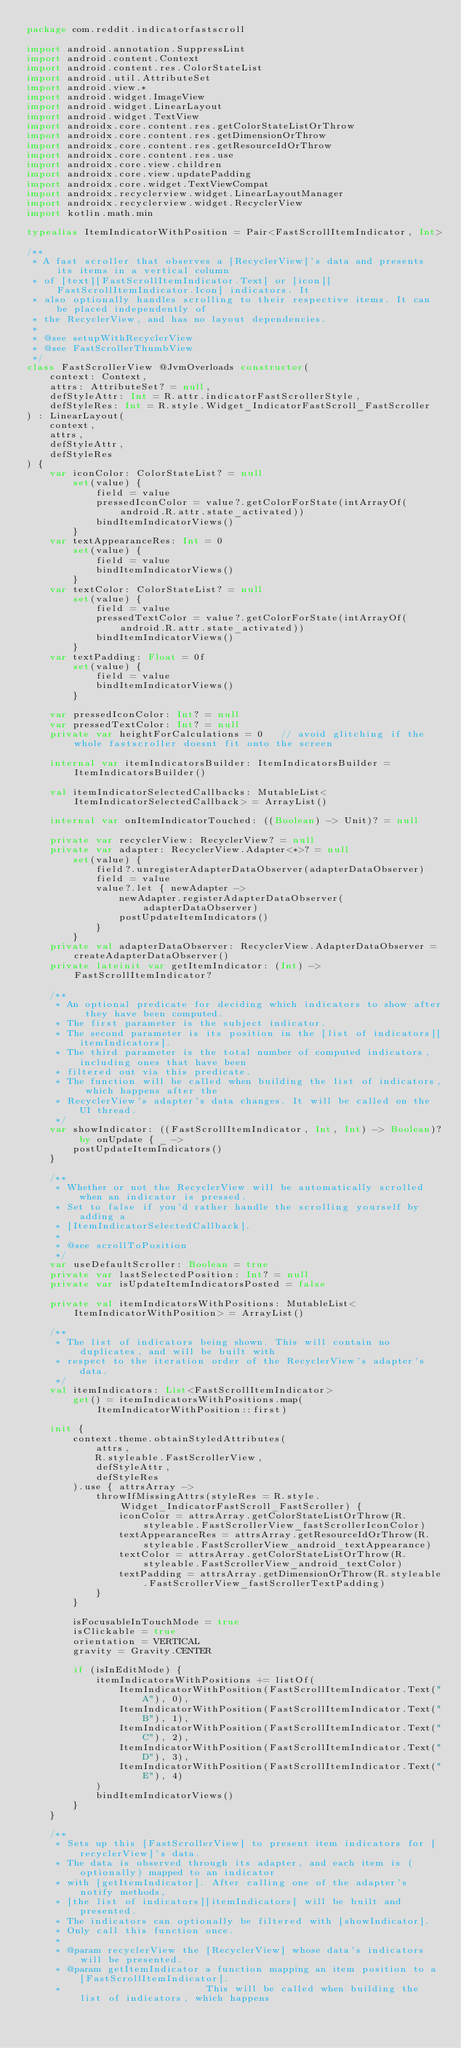Convert code to text. <code><loc_0><loc_0><loc_500><loc_500><_Kotlin_>package com.reddit.indicatorfastscroll

import android.annotation.SuppressLint
import android.content.Context
import android.content.res.ColorStateList
import android.util.AttributeSet
import android.view.*
import android.widget.ImageView
import android.widget.LinearLayout
import android.widget.TextView
import androidx.core.content.res.getColorStateListOrThrow
import androidx.core.content.res.getDimensionOrThrow
import androidx.core.content.res.getResourceIdOrThrow
import androidx.core.content.res.use
import androidx.core.view.children
import androidx.core.view.updatePadding
import androidx.core.widget.TextViewCompat
import androidx.recyclerview.widget.LinearLayoutManager
import androidx.recyclerview.widget.RecyclerView
import kotlin.math.min

typealias ItemIndicatorWithPosition = Pair<FastScrollItemIndicator, Int>

/**
 * A fast scroller that observes a [RecyclerView]'s data and presents its items in a vertical column
 * of [text][FastScrollItemIndicator.Text] or [icon][FastScrollItemIndicator.Icon] indicators. It
 * also optionally handles scrolling to their respective items. It can be placed independently of
 * the RecyclerView, and has no layout dependencies.
 *
 * @see setupWithRecyclerView
 * @see FastScrollerThumbView
 */
class FastScrollerView @JvmOverloads constructor(
    context: Context,
    attrs: AttributeSet? = null,
    defStyleAttr: Int = R.attr.indicatorFastScrollerStyle,
    defStyleRes: Int = R.style.Widget_IndicatorFastScroll_FastScroller
) : LinearLayout(
    context,
    attrs,
    defStyleAttr,
    defStyleRes
) {
    var iconColor: ColorStateList? = null
        set(value) {
            field = value
            pressedIconColor = value?.getColorForState(intArrayOf(android.R.attr.state_activated))
            bindItemIndicatorViews()
        }
    var textAppearanceRes: Int = 0
        set(value) {
            field = value
            bindItemIndicatorViews()
        }
    var textColor: ColorStateList? = null
        set(value) {
            field = value
            pressedTextColor = value?.getColorForState(intArrayOf(android.R.attr.state_activated))
            bindItemIndicatorViews()
        }
    var textPadding: Float = 0f
        set(value) {
            field = value
            bindItemIndicatorViews()
        }

    var pressedIconColor: Int? = null
    var pressedTextColor: Int? = null
    private var heightForCalculations = 0   // avoid glitching if the whole fastscroller doesnt fit onto the screen

    internal var itemIndicatorsBuilder: ItemIndicatorsBuilder = ItemIndicatorsBuilder()

    val itemIndicatorSelectedCallbacks: MutableList<ItemIndicatorSelectedCallback> = ArrayList()

    internal var onItemIndicatorTouched: ((Boolean) -> Unit)? = null

    private var recyclerView: RecyclerView? = null
    private var adapter: RecyclerView.Adapter<*>? = null
        set(value) {
            field?.unregisterAdapterDataObserver(adapterDataObserver)
            field = value
            value?.let { newAdapter ->
                newAdapter.registerAdapterDataObserver(adapterDataObserver)
                postUpdateItemIndicators()
            }
        }
    private val adapterDataObserver: RecyclerView.AdapterDataObserver = createAdapterDataObserver()
    private lateinit var getItemIndicator: (Int) -> FastScrollItemIndicator?

    /**
     * An optional predicate for deciding which indicators to show after they have been computed.
     * The first parameter is the subject indicator.
     * The second parameter is its position in the [list of indicators][itemIndicators].
     * The third parameter is the total number of computed indicators, including ones that have been
     * filtered out via this predicate.
     * The function will be called when building the list of indicators, which happens after the
     * RecyclerView's adapter's data changes. It will be called on the UI thread.
     */
    var showIndicator: ((FastScrollItemIndicator, Int, Int) -> Boolean)? by onUpdate { _ ->
        postUpdateItemIndicators()
    }

    /**
     * Whether or not the RecyclerView will be automatically scrolled when an indicator is pressed.
     * Set to false if you'd rather handle the scrolling yourself by adding a
     * [ItemIndicatorSelectedCallback].
     *
     * @see scrollToPosition
     */
    var useDefaultScroller: Boolean = true
    private var lastSelectedPosition: Int? = null
    private var isUpdateItemIndicatorsPosted = false

    private val itemIndicatorsWithPositions: MutableList<ItemIndicatorWithPosition> = ArrayList()

    /**
     * The list of indicators being shown. This will contain no duplicates, and will be built with
     * respect to the iteration order of the RecyclerView's adapter's data.
     */
    val itemIndicators: List<FastScrollItemIndicator>
        get() = itemIndicatorsWithPositions.map(ItemIndicatorWithPosition::first)

    init {
        context.theme.obtainStyledAttributes(
            attrs,
            R.styleable.FastScrollerView,
            defStyleAttr,
            defStyleRes
        ).use { attrsArray ->
            throwIfMissingAttrs(styleRes = R.style.Widget_IndicatorFastScroll_FastScroller) {
                iconColor = attrsArray.getColorStateListOrThrow(R.styleable.FastScrollerView_fastScrollerIconColor)
                textAppearanceRes = attrsArray.getResourceIdOrThrow(R.styleable.FastScrollerView_android_textAppearance)
                textColor = attrsArray.getColorStateListOrThrow(R.styleable.FastScrollerView_android_textColor)
                textPadding = attrsArray.getDimensionOrThrow(R.styleable.FastScrollerView_fastScrollerTextPadding)
            }
        }

        isFocusableInTouchMode = true
        isClickable = true
        orientation = VERTICAL
        gravity = Gravity.CENTER

        if (isInEditMode) {
            itemIndicatorsWithPositions += listOf(
                ItemIndicatorWithPosition(FastScrollItemIndicator.Text("A"), 0),
                ItemIndicatorWithPosition(FastScrollItemIndicator.Text("B"), 1),
                ItemIndicatorWithPosition(FastScrollItemIndicator.Text("C"), 2),
                ItemIndicatorWithPosition(FastScrollItemIndicator.Text("D"), 3),
                ItemIndicatorWithPosition(FastScrollItemIndicator.Text("E"), 4)
            )
            bindItemIndicatorViews()
        }
    }

    /**
     * Sets up this [FastScrollerView] to present item indicators for [recyclerView]'s data.
     * The data is observed through its adapter, and each item is (optionally) mapped to an indicator
     * with [getItemIndicator]. After calling one of the adapter's notify methods,
     * [the list of indicators][itemIndicators] will be built and presented.
     * The indicators can optionally be filtered with [showIndicator].
     * Only call this function once.
     *
     * @param recyclerView the [RecyclerView] whose data's indicators will be presented.
     * @param getItemIndicator a function mapping an item position to a [FastScrollItemIndicator].
     *                         This will be called when building the list of indicators, which happens</code> 